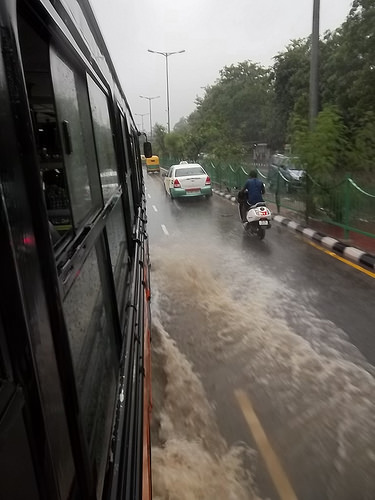<image>
Is the car on the bike? No. The car is not positioned on the bike. They may be near each other, but the car is not supported by or resting on top of the bike. 